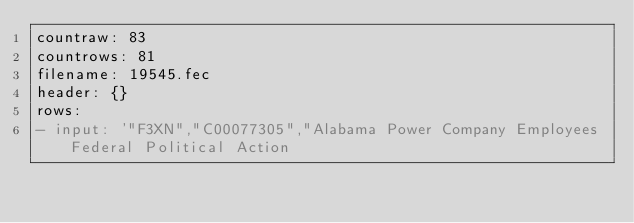Convert code to text. <code><loc_0><loc_0><loc_500><loc_500><_YAML_>countraw: 83
countrows: 81
filename: 19545.fec
header: {}
rows:
- input: '"F3XN","C00077305","Alabama Power Company Employees Federal Political Action</code> 